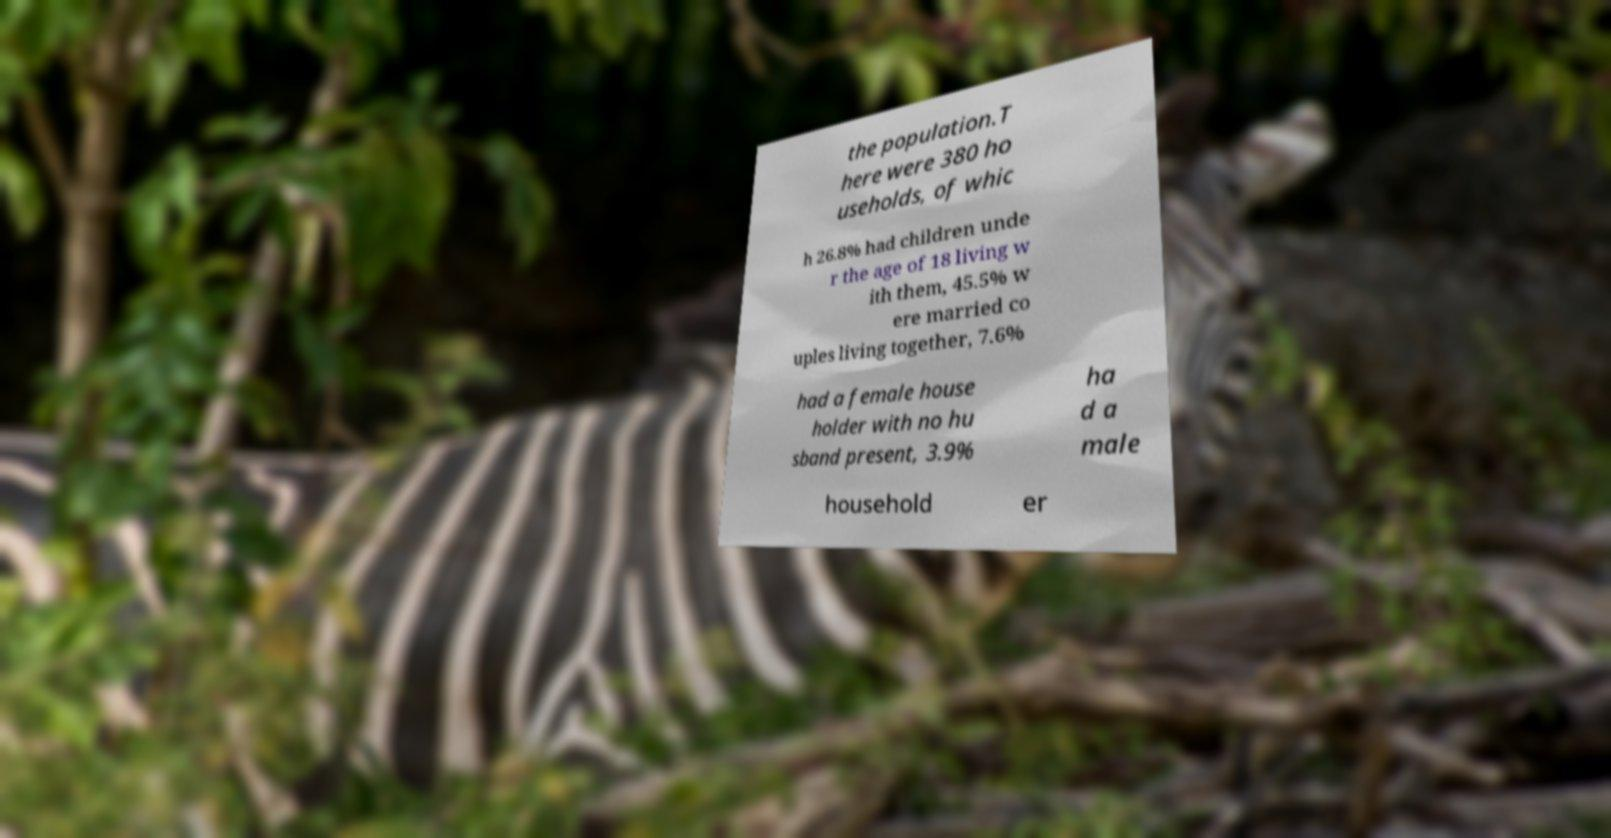Can you read and provide the text displayed in the image?This photo seems to have some interesting text. Can you extract and type it out for me? the population.T here were 380 ho useholds, of whic h 26.8% had children unde r the age of 18 living w ith them, 45.5% w ere married co uples living together, 7.6% had a female house holder with no hu sband present, 3.9% ha d a male household er 